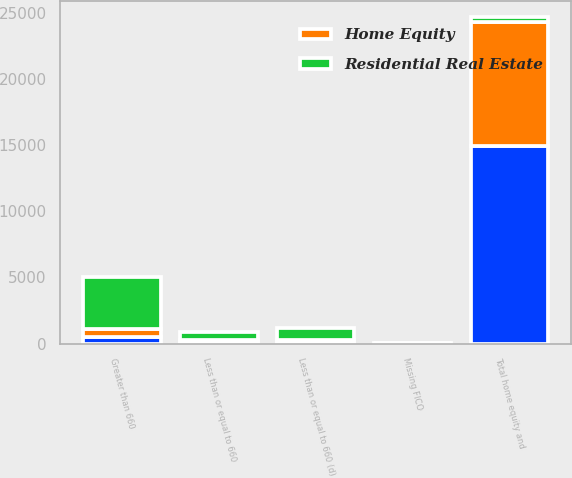<chart> <loc_0><loc_0><loc_500><loc_500><stacked_bar_chart><ecel><fcel>Greater than 660<fcel>Less than or equal to 660 (d)<fcel>Missing FICO<fcel>Less than or equal to 660<fcel>Total home equity and<nl><fcel>nan<fcel>470<fcel>84<fcel>1<fcel>130<fcel>14904<nl><fcel>Home Equity<fcel>667<fcel>211<fcel>19<fcel>164<fcel>9425<nl><fcel>Residential Real Estate<fcel>3909<fcel>884<fcel>30<fcel>613<fcel>340.5<nl></chart> 